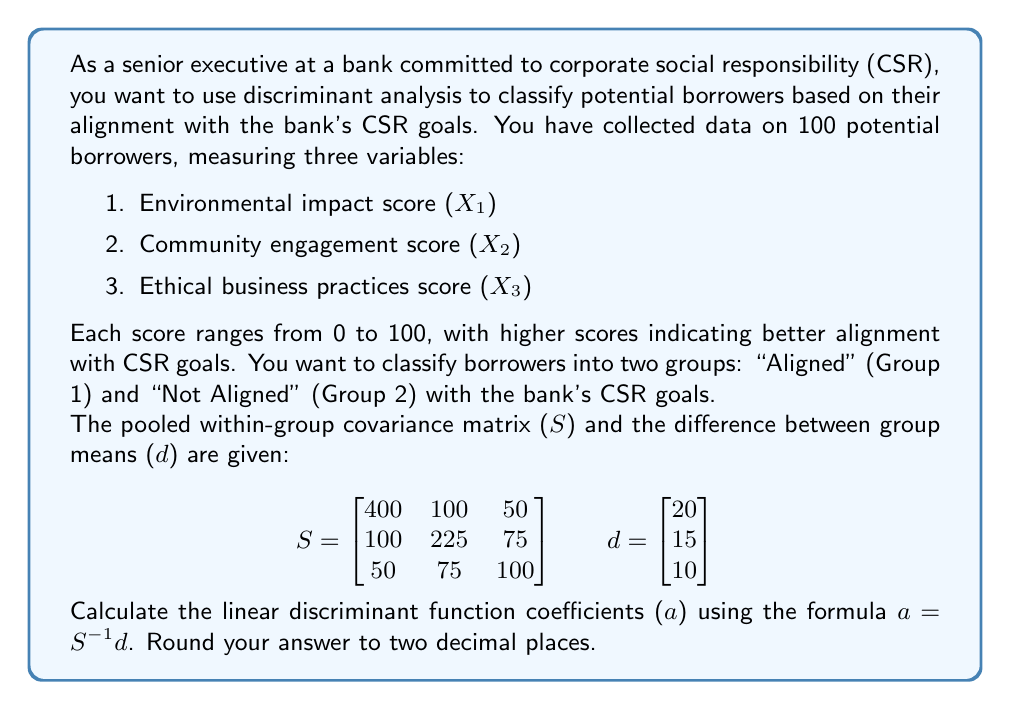Give your solution to this math problem. To solve this problem, we need to follow these steps:

1. Calculate the inverse of the pooled within-group covariance matrix (S⁻¹).
2. Multiply S⁻¹ by the difference between group means (d) to get the linear discriminant function coefficients (a).

Step 1: Calculate S⁻¹

To find the inverse of S, we can use the matrix inversion formula or a calculator. The inverse of S is:

$$S^{-1} = \begin{bmatrix}
0.00288 & -0.00121 & -0.00076 \\
-0.00121 & 0.00538 & -0.00326 \\
-0.00076 & -0.00326 & 0.01152
\end{bmatrix}$$

Step 2: Calculate a = S⁻¹d

Now we multiply S⁻¹ by d:

$$a = S^{-1}d = \begin{bmatrix}
0.00288 & -0.00121 & -0.00076 \\
-0.00121 & 0.00538 & -0.00326 \\
-0.00076 & -0.00326 & 0.01152
\end{bmatrix} \times \begin{bmatrix}
20 \\
15 \\
10
\end{bmatrix}$$

Performing the matrix multiplication:

$$a = \begin{bmatrix}
(0.00288 \times 20) + (-0.00121 \times 15) + (-0.00076 \times 10) \\
(-0.00121 \times 20) + (0.00538 \times 15) + (-0.00326 \times 10) \\
(-0.00076 \times 20) + (-0.00326 \times 15) + (0.01152 \times 10)
\end{bmatrix}$$

$$a = \begin{bmatrix}
0.0576 - 0.01815 - 0.0076 \\
-0.0242 + 0.0807 - 0.0326 \\
-0.0152 - 0.0489 + 0.1152
\end{bmatrix}$$

$$a = \begin{bmatrix}
0.03185 \\
0.0239 \\
0.0511
\end{bmatrix}$$

Rounding to two decimal places:

$$a = \begin{bmatrix}
0.03 \\
0.02 \\
0.05
\end{bmatrix}$$
Answer: $a = [0.03, 0.02, 0.05]$ 